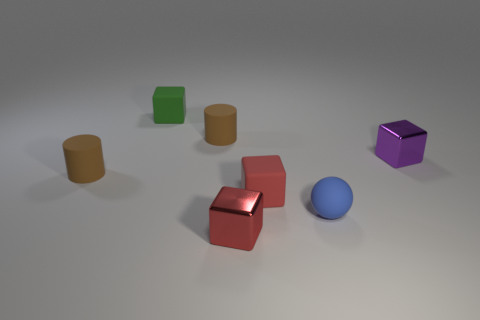Add 1 tiny blue cylinders. How many objects exist? 8 Subtract all blocks. How many objects are left? 3 Add 6 yellow matte blocks. How many yellow matte blocks exist? 6 Subtract 0 purple cylinders. How many objects are left? 7 Subtract all purple things. Subtract all tiny red objects. How many objects are left? 4 Add 1 small red cubes. How many small red cubes are left? 3 